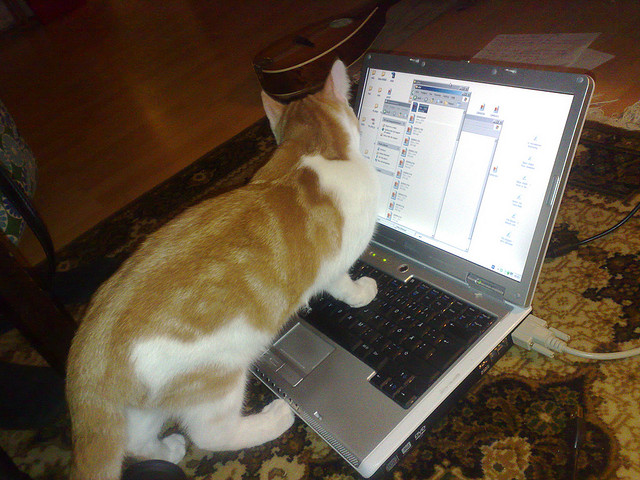<image>Why is the cat on the laptop? It is unknown why the cat is on the laptop. It could be due to curiosity or playfulness. Why is the cat on the laptop? I don't know why the cat is on the laptop. It can be because the cat is curious or playing. 